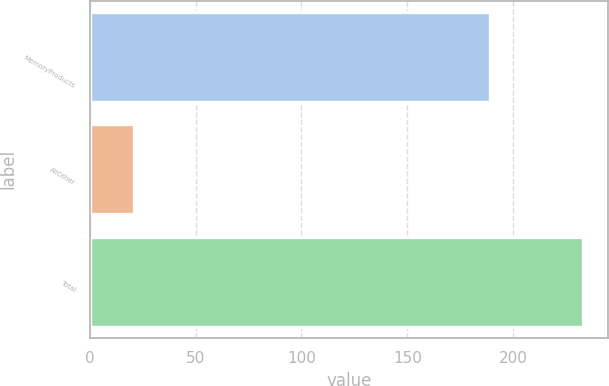Convert chart to OTSL. <chart><loc_0><loc_0><loc_500><loc_500><bar_chart><fcel>MemoryProducts<fcel>AllOther<fcel>Total<nl><fcel>189<fcel>21<fcel>233<nl></chart> 